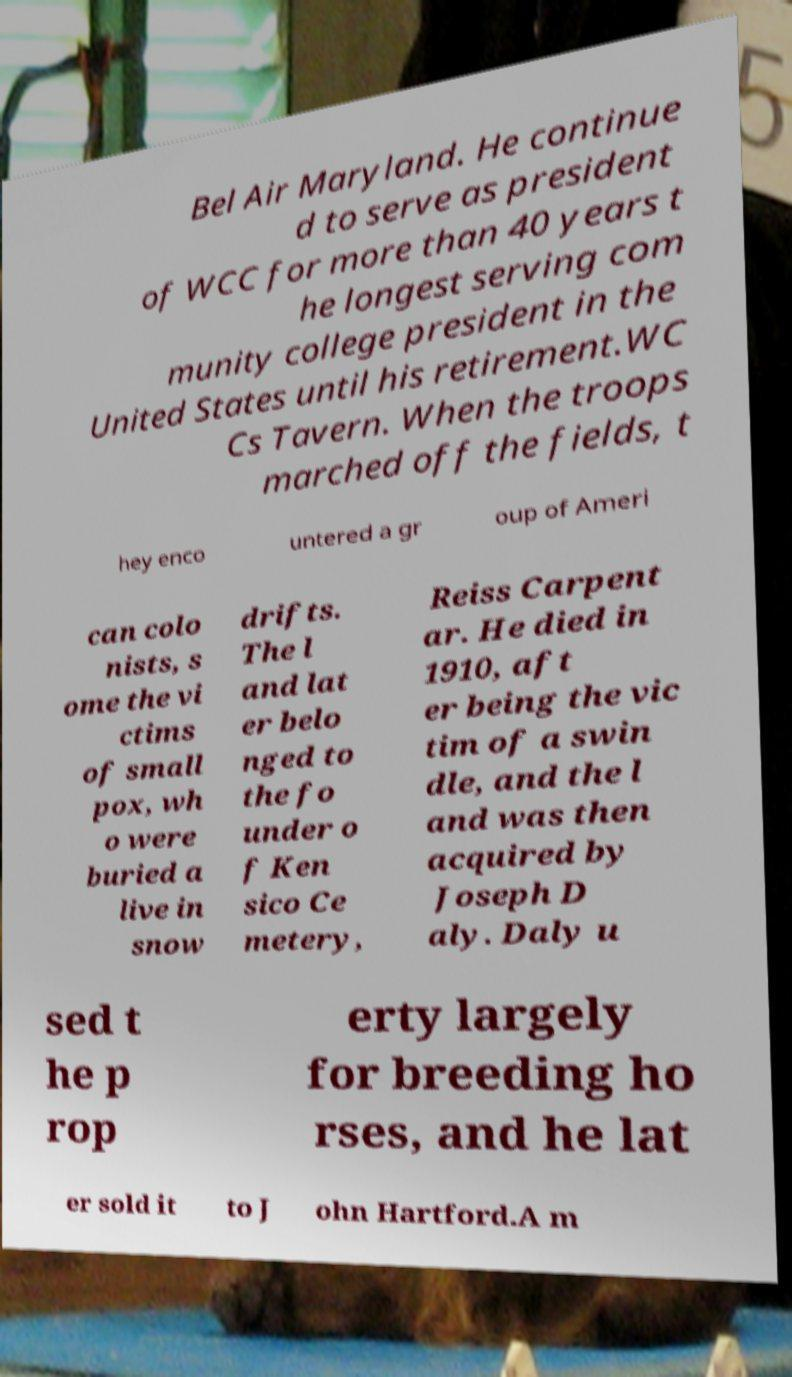Please read and relay the text visible in this image. What does it say? Bel Air Maryland. He continue d to serve as president of WCC for more than 40 years t he longest serving com munity college president in the United States until his retirement.WC Cs Tavern. When the troops marched off the fields, t hey enco untered a gr oup of Ameri can colo nists, s ome the vi ctims of small pox, wh o were buried a live in snow drifts. The l and lat er belo nged to the fo under o f Ken sico Ce metery, Reiss Carpent ar. He died in 1910, aft er being the vic tim of a swin dle, and the l and was then acquired by Joseph D aly. Daly u sed t he p rop erty largely for breeding ho rses, and he lat er sold it to J ohn Hartford.A m 